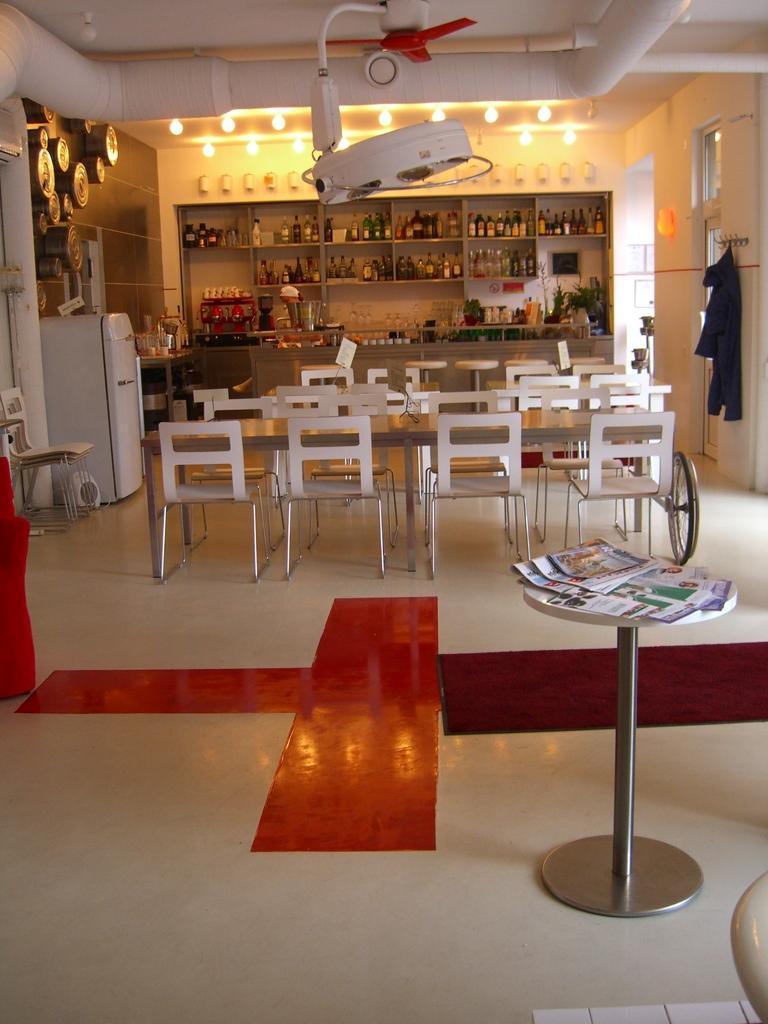How would you summarize this image in a sentence or two? As we can see in the image there is a refrigerator, chairs, tables, books, fan, shelves filled with bottles and there are lights. 